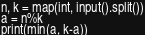Convert code to text. <code><loc_0><loc_0><loc_500><loc_500><_Python_>n, k = map(int, input().split())
a = n%k
print(min(a, k-a))</code> 